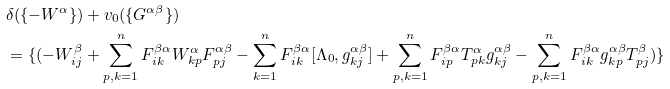<formula> <loc_0><loc_0><loc_500><loc_500>& \delta ( \{ - W ^ { \alpha } \} ) + v _ { 0 } ( \{ G ^ { \alpha \beta } \} ) \\ & = \{ ( - W _ { i j } ^ { \beta } + \sum _ { p , k = 1 } ^ { n } F ^ { \beta \alpha } _ { i k } W _ { k p } ^ { \alpha } F ^ { \alpha \beta } _ { p j } - \sum _ { k = 1 } ^ { n } F _ { i k } ^ { \beta \alpha } [ \Lambda _ { 0 } , g _ { k j } ^ { \alpha \beta } ] + \sum _ { p , k = 1 } ^ { n } F ^ { \beta \alpha } _ { i p } T _ { p k } ^ { \alpha } g _ { k j } ^ { \alpha \beta } - \sum _ { p , k = 1 } ^ { n } F ^ { \beta \alpha } _ { i k } g ^ { \alpha \beta } _ { k p } T _ { p j } ^ { \beta } ) \}</formula> 